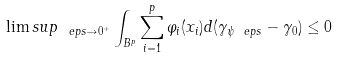<formula> <loc_0><loc_0><loc_500><loc_500>\lim s u p _ { \ e p s \to 0 ^ { + } } \int _ { B ^ { p } } \sum _ { i = 1 } ^ { p } \varphi _ { i } ( x _ { i } ) d ( \gamma _ { \psi _ { \ } e p s } - \gamma _ { 0 } ) \leq 0</formula> 